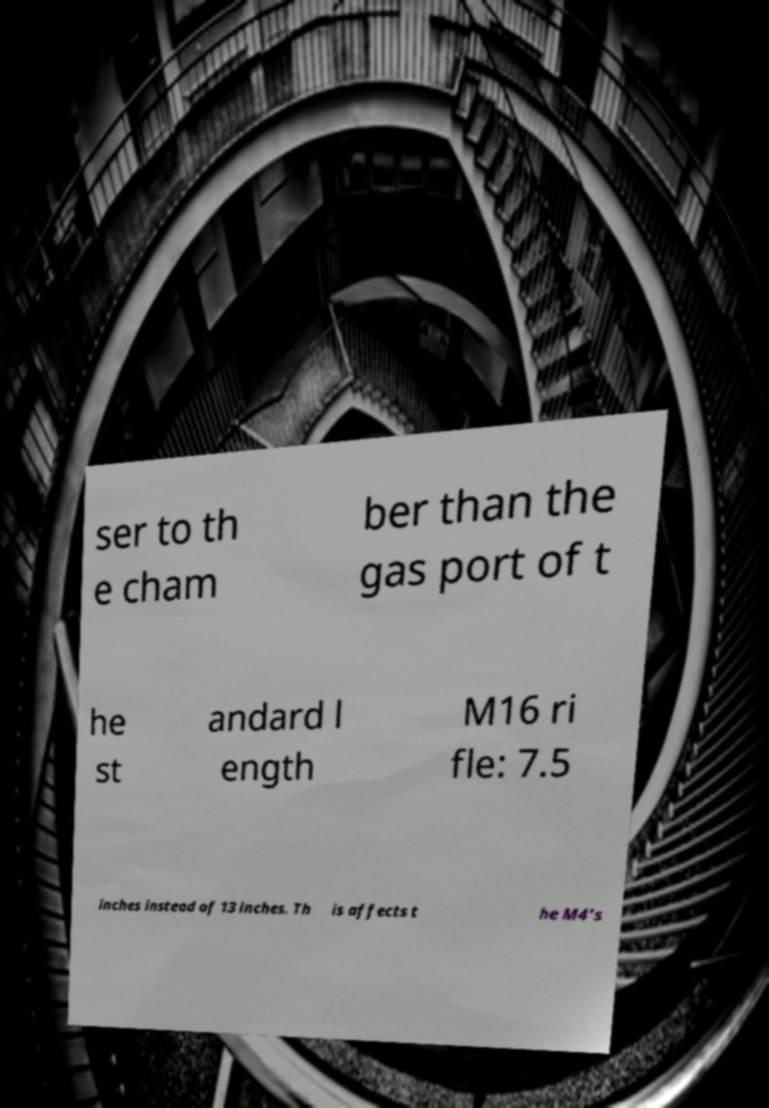What messages or text are displayed in this image? I need them in a readable, typed format. ser to th e cham ber than the gas port of t he st andard l ength M16 ri fle: 7.5 inches instead of 13 inches. Th is affects t he M4's 